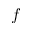Convert formula to latex. <formula><loc_0><loc_0><loc_500><loc_500>f</formula> 